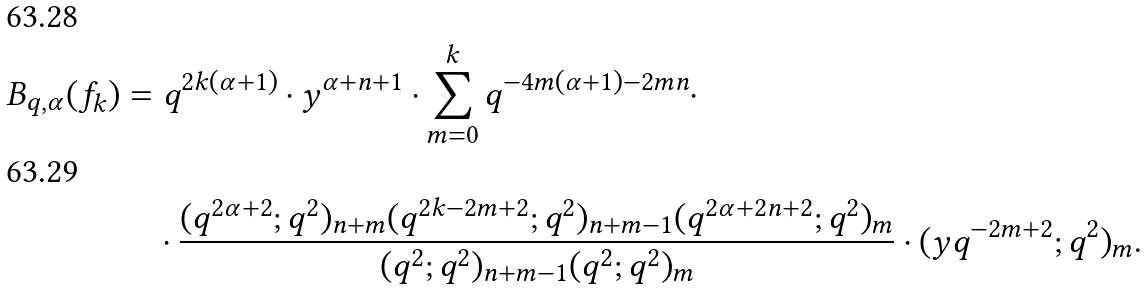Convert formula to latex. <formula><loc_0><loc_0><loc_500><loc_500>B _ { q , \alpha } ( f _ { k } ) & = q ^ { 2 k ( \alpha + 1 ) } \cdot y ^ { \alpha + n + 1 } \cdot \sum _ { m = 0 } ^ { k } q ^ { - 4 m ( \alpha + 1 ) - 2 m n } \cdot \\ & \quad \cdot \frac { ( q ^ { 2 \alpha + 2 } ; q ^ { 2 } ) _ { n + m } ( q ^ { 2 k - 2 m + 2 } ; q ^ { 2 } ) _ { n + m - 1 } ( q ^ { 2 \alpha + 2 n + 2 } ; q ^ { 2 } ) _ { m } } { ( q ^ { 2 } ; q ^ { 2 } ) _ { n + m - 1 } ( q ^ { 2 } ; q ^ { 2 } ) _ { m } } \cdot ( y q ^ { - 2 m + 2 } ; q ^ { 2 } ) _ { m } .</formula> 